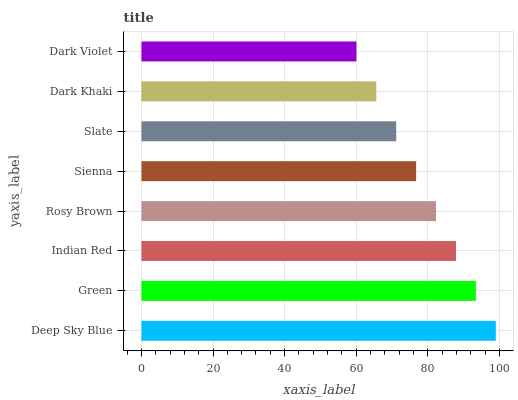Is Dark Violet the minimum?
Answer yes or no. Yes. Is Deep Sky Blue the maximum?
Answer yes or no. Yes. Is Green the minimum?
Answer yes or no. No. Is Green the maximum?
Answer yes or no. No. Is Deep Sky Blue greater than Green?
Answer yes or no. Yes. Is Green less than Deep Sky Blue?
Answer yes or no. Yes. Is Green greater than Deep Sky Blue?
Answer yes or no. No. Is Deep Sky Blue less than Green?
Answer yes or no. No. Is Rosy Brown the high median?
Answer yes or no. Yes. Is Sienna the low median?
Answer yes or no. Yes. Is Indian Red the high median?
Answer yes or no. No. Is Rosy Brown the low median?
Answer yes or no. No. 